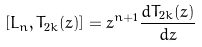Convert formula to latex. <formula><loc_0><loc_0><loc_500><loc_500>[ L _ { n } , T _ { 2 k } ( z ) ] = z ^ { n + 1 } \frac { d T _ { 2 k } ( z ) } { d z }</formula> 